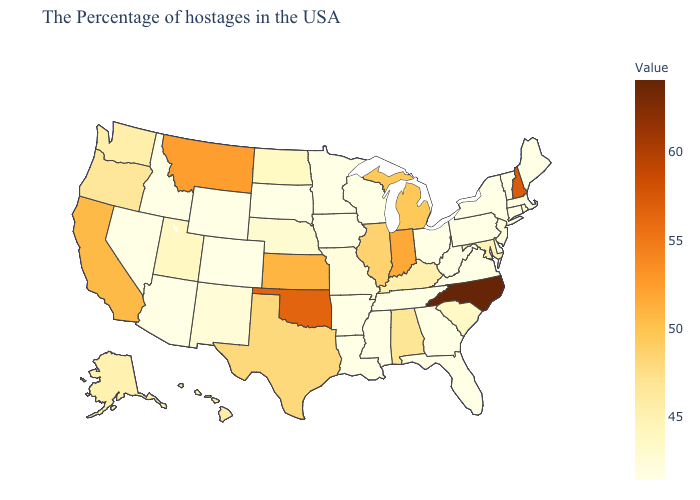Does Georgia have the lowest value in the USA?
Be succinct. Yes. Among the states that border Connecticut , which have the lowest value?
Quick response, please. New York. Which states have the highest value in the USA?
Short answer required. North Carolina. Which states hav the highest value in the South?
Answer briefly. North Carolina. Among the states that border Florida , does Alabama have the highest value?
Write a very short answer. Yes. 